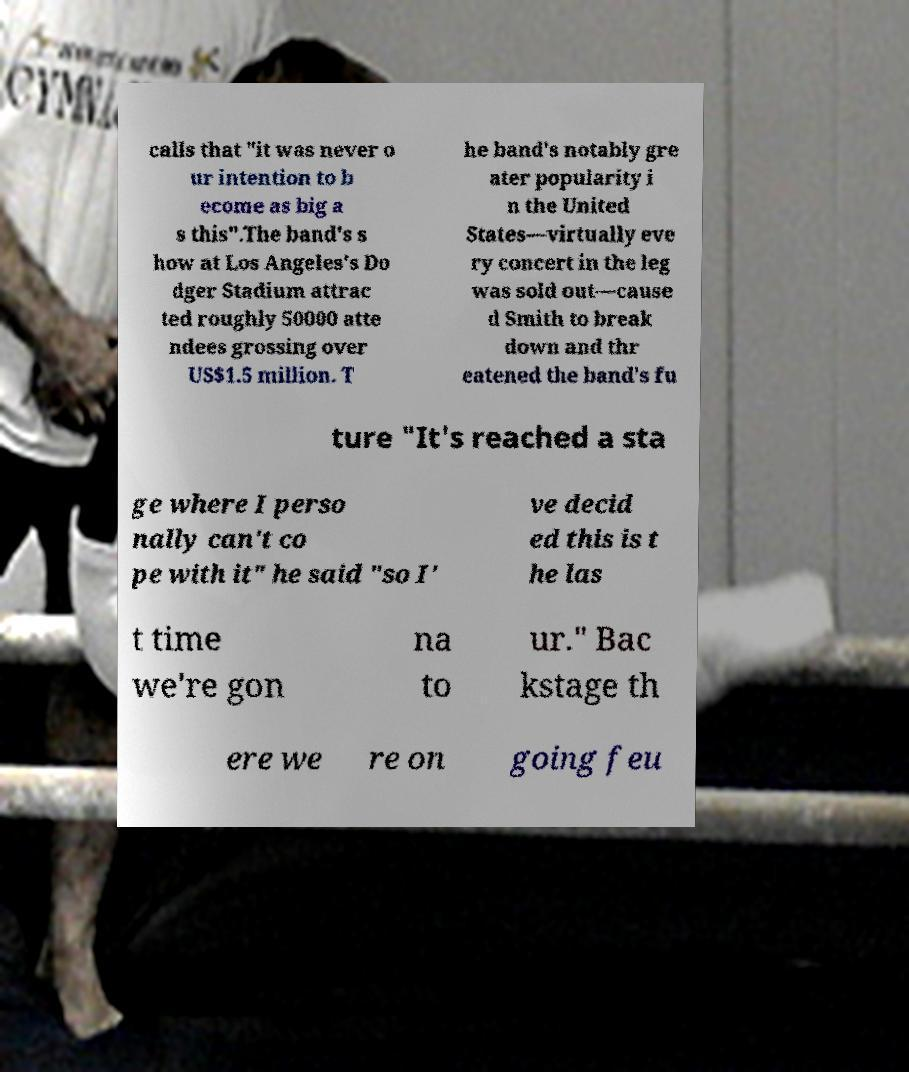I need the written content from this picture converted into text. Can you do that? calls that "it was never o ur intention to b ecome as big a s this".The band's s how at Los Angeles's Do dger Stadium attrac ted roughly 50000 atte ndees grossing over US$1.5 million. T he band's notably gre ater popularity i n the United States—virtually eve ry concert in the leg was sold out—cause d Smith to break down and thr eatened the band's fu ture "It's reached a sta ge where I perso nally can't co pe with it" he said "so I' ve decid ed this is t he las t time we're gon na to ur." Bac kstage th ere we re on going feu 